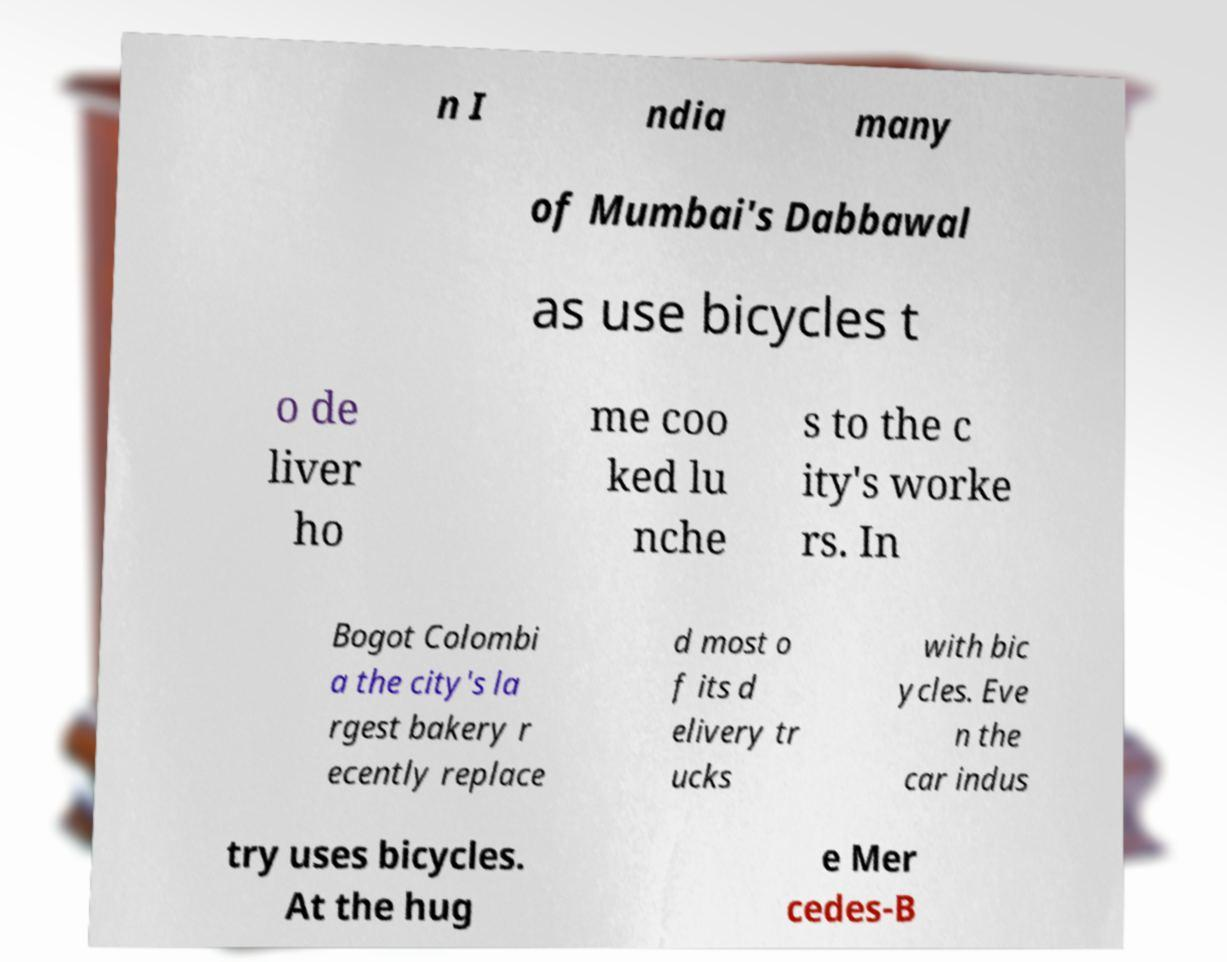For documentation purposes, I need the text within this image transcribed. Could you provide that? n I ndia many of Mumbai's Dabbawal as use bicycles t o de liver ho me coo ked lu nche s to the c ity's worke rs. In Bogot Colombi a the city's la rgest bakery r ecently replace d most o f its d elivery tr ucks with bic ycles. Eve n the car indus try uses bicycles. At the hug e Mer cedes-B 